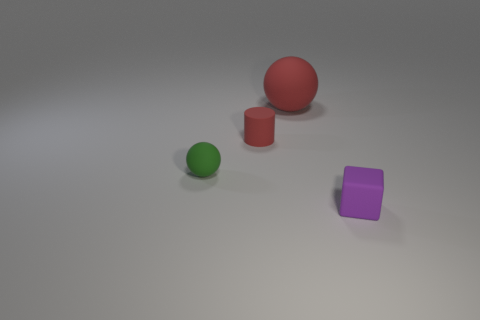Add 3 red balls. How many objects exist? 7 Subtract all red balls. How many balls are left? 1 Subtract all cylinders. How many objects are left? 3 Subtract 1 cylinders. How many cylinders are left? 0 Subtract all cyan cubes. Subtract all brown cylinders. How many cubes are left? 1 Subtract 1 red cylinders. How many objects are left? 3 Subtract all blue blocks. How many green spheres are left? 1 Subtract all small matte blocks. Subtract all large matte spheres. How many objects are left? 2 Add 2 purple matte cubes. How many purple matte cubes are left? 3 Add 2 large rubber things. How many large rubber things exist? 3 